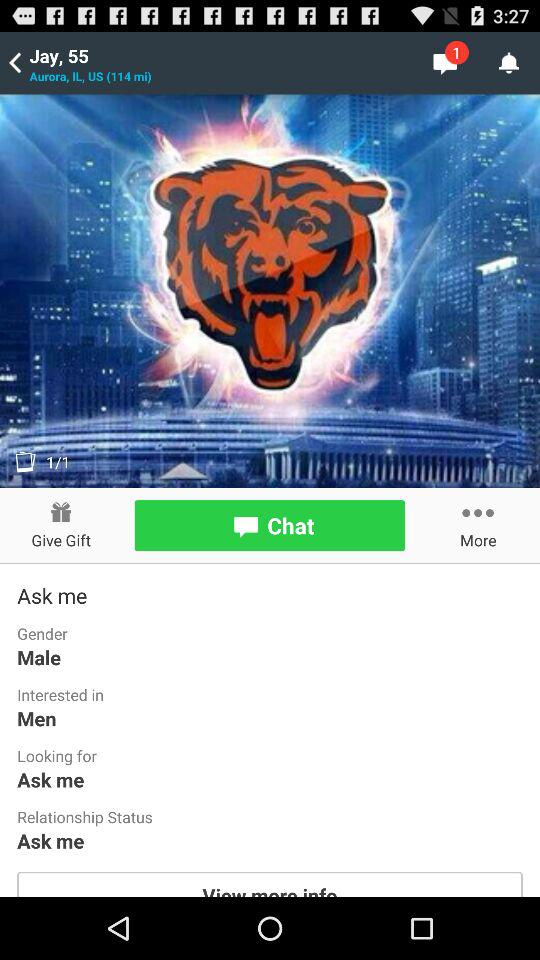How many options are there for the user to select for their gender?
Answer the question using a single word or phrase. 2 